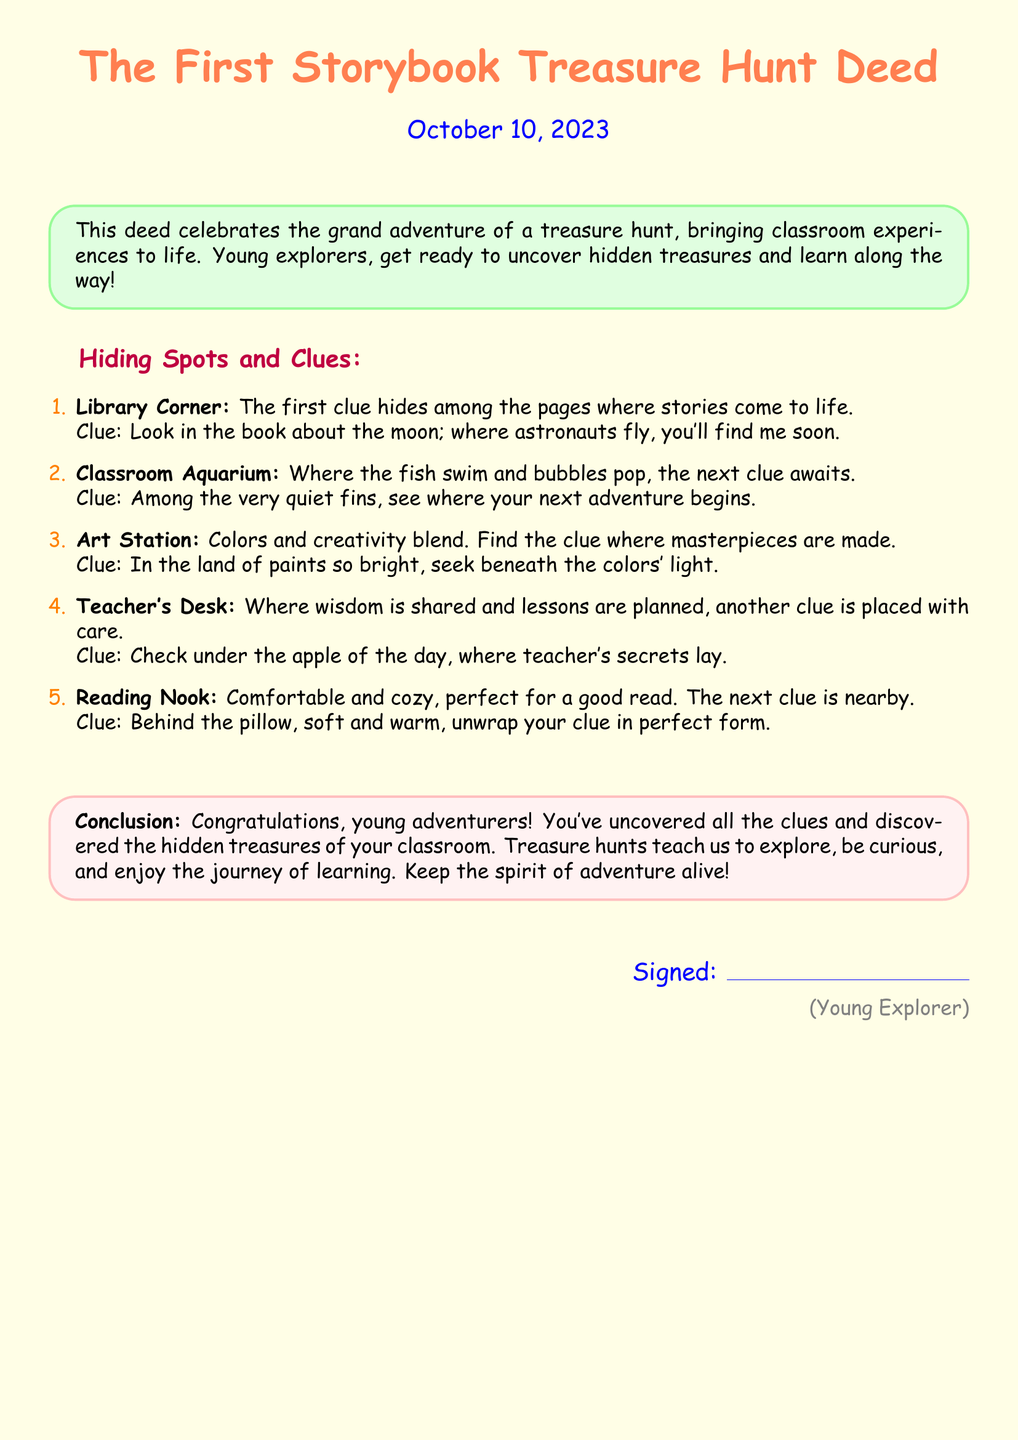What is the title of the document? The title of the document is prominently displayed at the top, identifying the purpose of the document.
Answer: The First Storybook Treasure Hunt Deed When was the deed created? The date is mentioned right below the title, indicating when the deed was signed.
Answer: October 10, 2023 How many hiding spots are listed? The total number of hiding spots is specified in the enumeration at the beginning of the clues section.
Answer: 5 What is the first hiding spot mentioned? The first hiding spot is given in the enumeration, serving as the starting point of the treasure hunt.
Answer: Library Corner What is the clue for the aquarium? The clue associated with the aquarium provides guidance for finding the treasure in that location.
Answer: Among the very quiet fins, see where your next adventure begins What do young adventurers uncover? The conclusion section of the document highlights what the treasure hunt teaches young explorers after they complete the hunt.
Answer: Hidden treasures Where should you check for the clue under the teacher's desk? The clue for the teacher's desk specifies the item under which the next clue can be found.
Answer: Apple of the day What type of experience does the deed celebrate? The purpose of the deed is highlighted in the introductory box, summarizing the theme of the adventure.
Answer: Treasure hunt Who signs the deed at the end? The signing section indicates who is responsible for the completion of the deed.
Answer: Young Explorer 